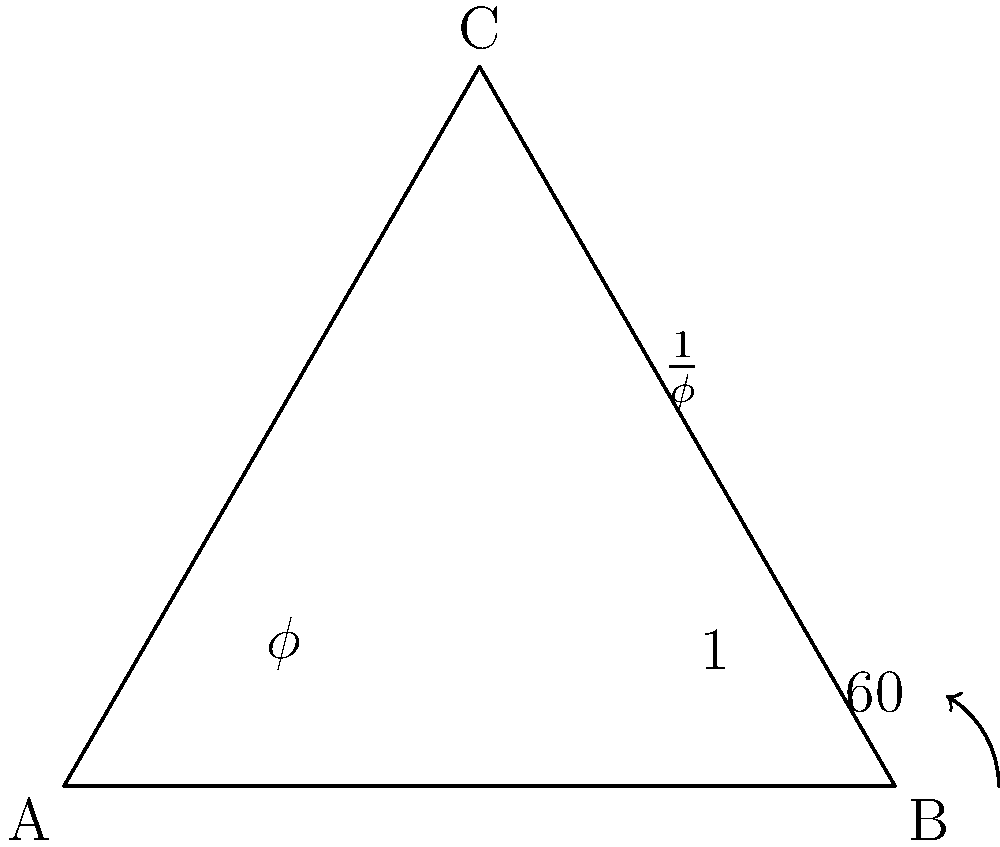In this golden triangle, angle C measures 60°, and the ratio of the longer side to the shorter side is the golden ratio ($\phi$). If the shorter side has a length of 1, what is the measure of angle A to the nearest degree? Let's approach this step-by-step:

1) In a golden triangle, the ratio of the longer side to the shorter side is $\phi$ (the golden ratio).

2) The golden ratio is approximately 1.618. Let's call the shorter side 1 and the longer side $\phi$.

3) We know that angle C is 60°. In an isosceles triangle, the base angles are equal. Therefore, angles A and B are equal.

4) The sum of angles in a triangle is always 180°. So:

   $A + B + C = 180°$
   $A + A + 60° = 180°$
   $2A + 60° = 180°$
   $2A = 120°$
   $A = 60°$

5) To verify, we can use the sine law:

   $\frac{a}{\sin A} = \frac{b}{\sin B} = \frac{c}{\sin C}$

   Where $a = 1$, $b = \phi$, and $C = 60°$

   $\frac{1}{\sin 60°} = \frac{\phi}{\sin A}$

   $\sin A = \frac{\phi \sin 60°}{1} \approx 0.8660$

   $A = \arcsin(0.8660) \approx 60°$

This confirms our algebraic solution.
Answer: 60° 